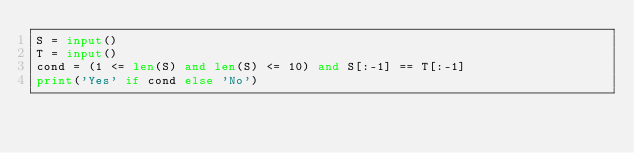<code> <loc_0><loc_0><loc_500><loc_500><_Python_>S = input()
T = input()
cond = (1 <= len(S) and len(S) <= 10) and S[:-1] == T[:-1]
print('Yes' if cond else 'No')
</code> 